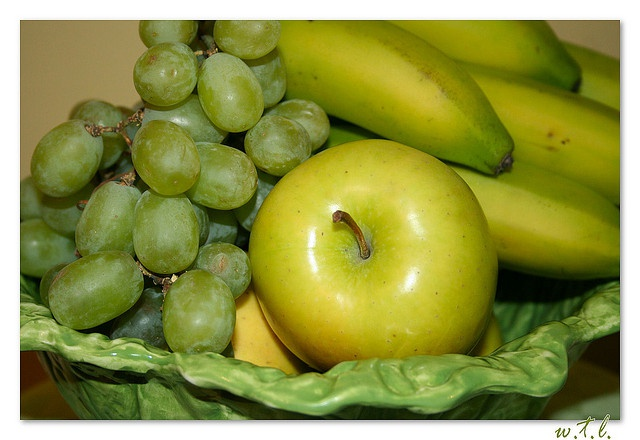Describe the objects in this image and their specific colors. I can see apple in white, olive, and khaki tones, bowl in white, black, olive, and darkgreen tones, banana in white, olive, and gold tones, banana in white, olive, and black tones, and banana in white, olive, and darkgreen tones in this image. 